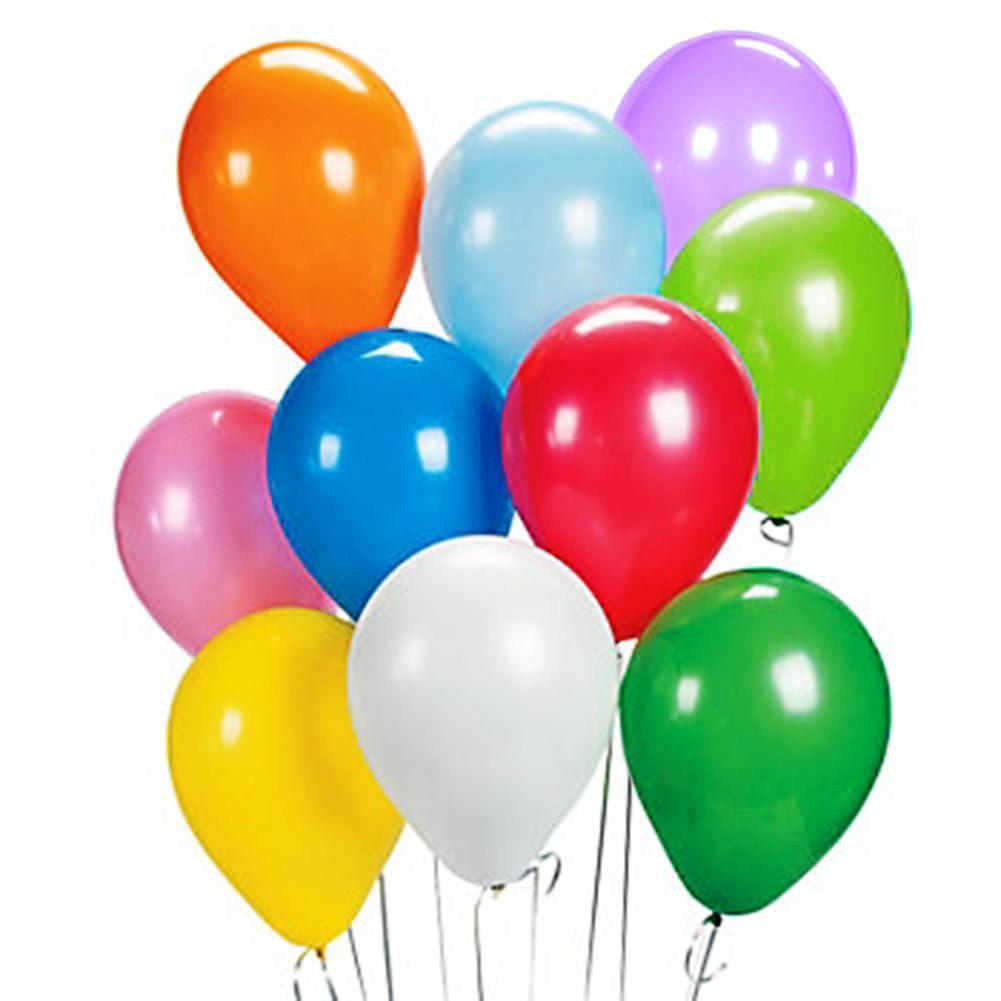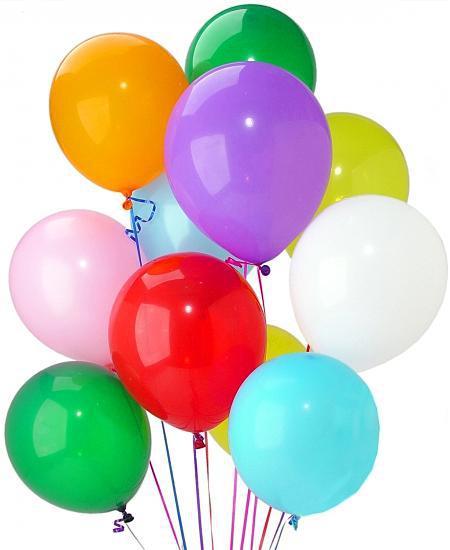The first image is the image on the left, the second image is the image on the right. Considering the images on both sides, is "The right image has exactly eleven balloons" valid? Answer yes or no. Yes. The first image is the image on the left, the second image is the image on the right. For the images shown, is this caption "The left and right image contains a bushel of balloons with strings and at least two balloons are green," true? Answer yes or no. Yes. 